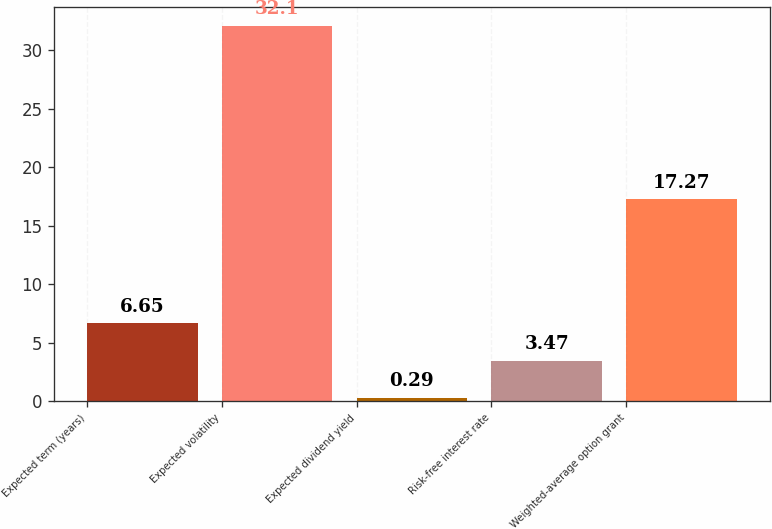Convert chart to OTSL. <chart><loc_0><loc_0><loc_500><loc_500><bar_chart><fcel>Expected term (years)<fcel>Expected volatility<fcel>Expected dividend yield<fcel>Risk-free interest rate<fcel>Weighted-average option grant<nl><fcel>6.65<fcel>32.1<fcel>0.29<fcel>3.47<fcel>17.27<nl></chart> 